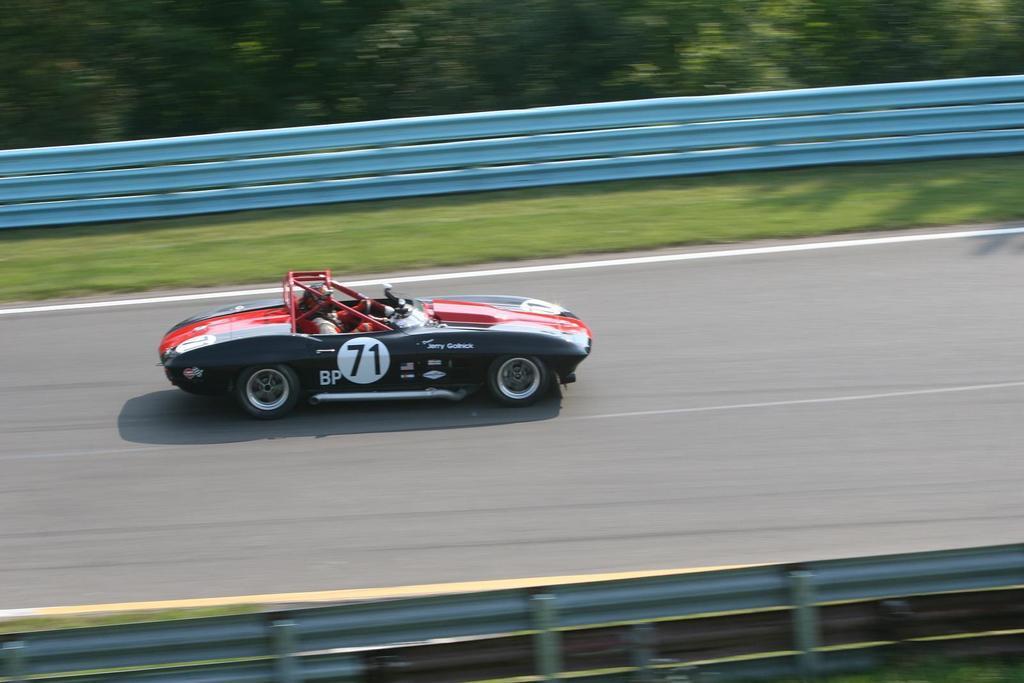Could you give a brief overview of what you see in this image? In this image there is a person riding sports car on the road, beside that there is grass, fence and trees. 